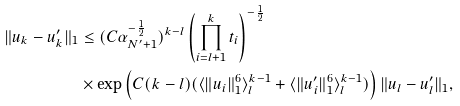<formula> <loc_0><loc_0><loc_500><loc_500>\| u _ { k } - u _ { k } ^ { \prime } \| _ { 1 } & \leq ( C \alpha _ { N ^ { \prime } + 1 } ^ { - \frac { 1 } { 2 } } ) ^ { k - l } \left ( \prod _ { i = l + 1 } ^ { k } t _ { i } \right ) ^ { - \frac { 1 } { 2 } } \\ & \times \exp \left ( C ( k - l ) ( \langle \| u _ { i } \| _ { 1 } ^ { 6 } \rangle _ { l } ^ { k - 1 } + \langle \| u _ { i } ^ { \prime } \| _ { 1 } ^ { 6 } \rangle _ { l } ^ { k - 1 } ) \right ) \| u _ { l } - u _ { l } ^ { \prime } \| _ { 1 } ,</formula> 